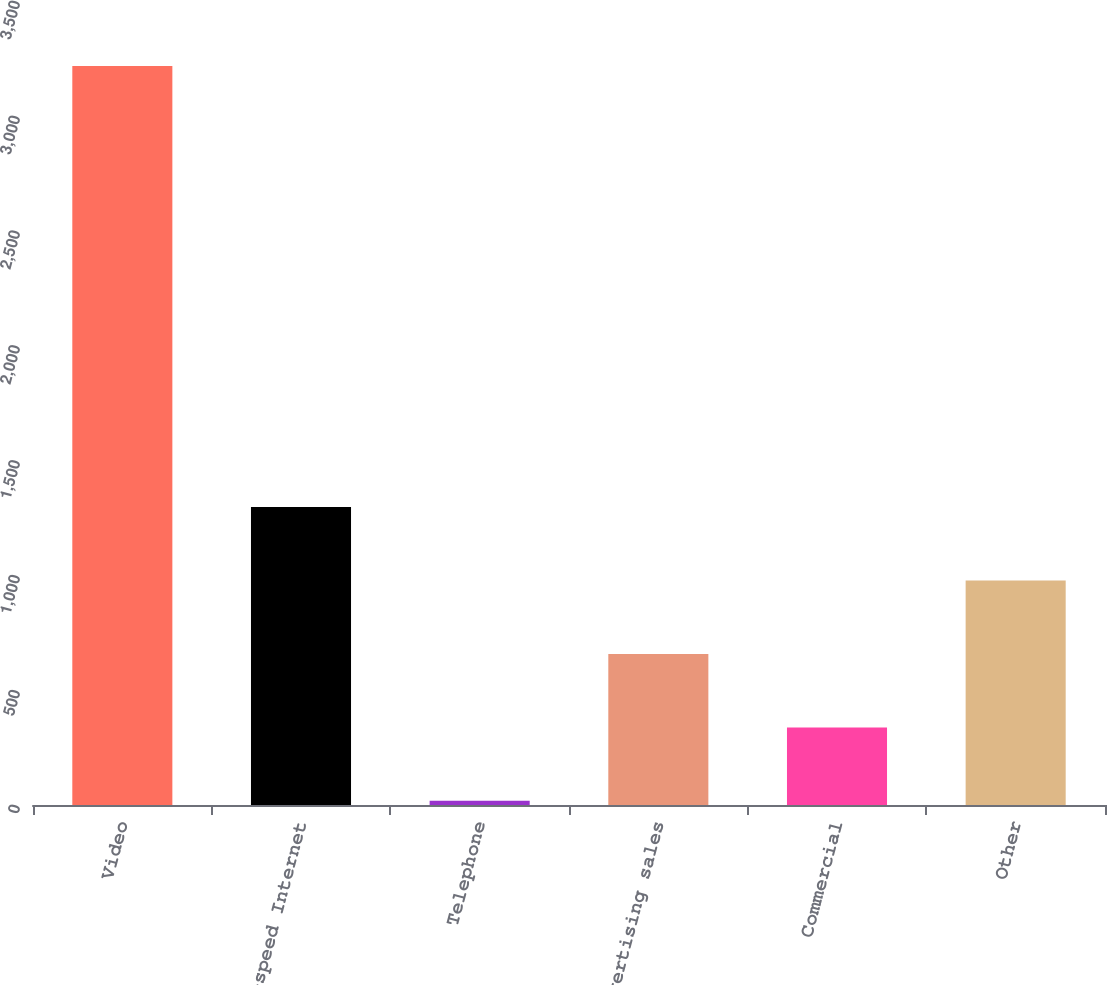Convert chart. <chart><loc_0><loc_0><loc_500><loc_500><bar_chart><fcel>Video<fcel>High-speed Internet<fcel>Telephone<fcel>Advertising sales<fcel>Commercial<fcel>Other<nl><fcel>3217<fcel>1297.6<fcel>18<fcel>657.8<fcel>337.9<fcel>977.7<nl></chart> 